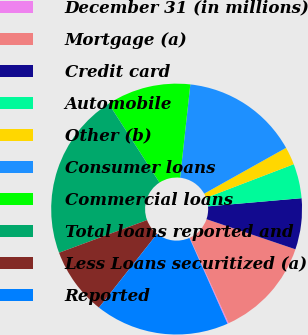<chart> <loc_0><loc_0><loc_500><loc_500><pie_chart><fcel>December 31 (in millions)<fcel>Mortgage (a)<fcel>Credit card<fcel>Automobile<fcel>Other (b)<fcel>Consumer loans<fcel>Commercial loans<fcel>Total loans reported and<fcel>Less Loans securitized (a)<fcel>Reported<nl><fcel>0.16%<fcel>13.0%<fcel>6.58%<fcel>4.44%<fcel>2.3%<fcel>15.14%<fcel>10.86%<fcel>21.56%<fcel>8.72%<fcel>17.28%<nl></chart> 